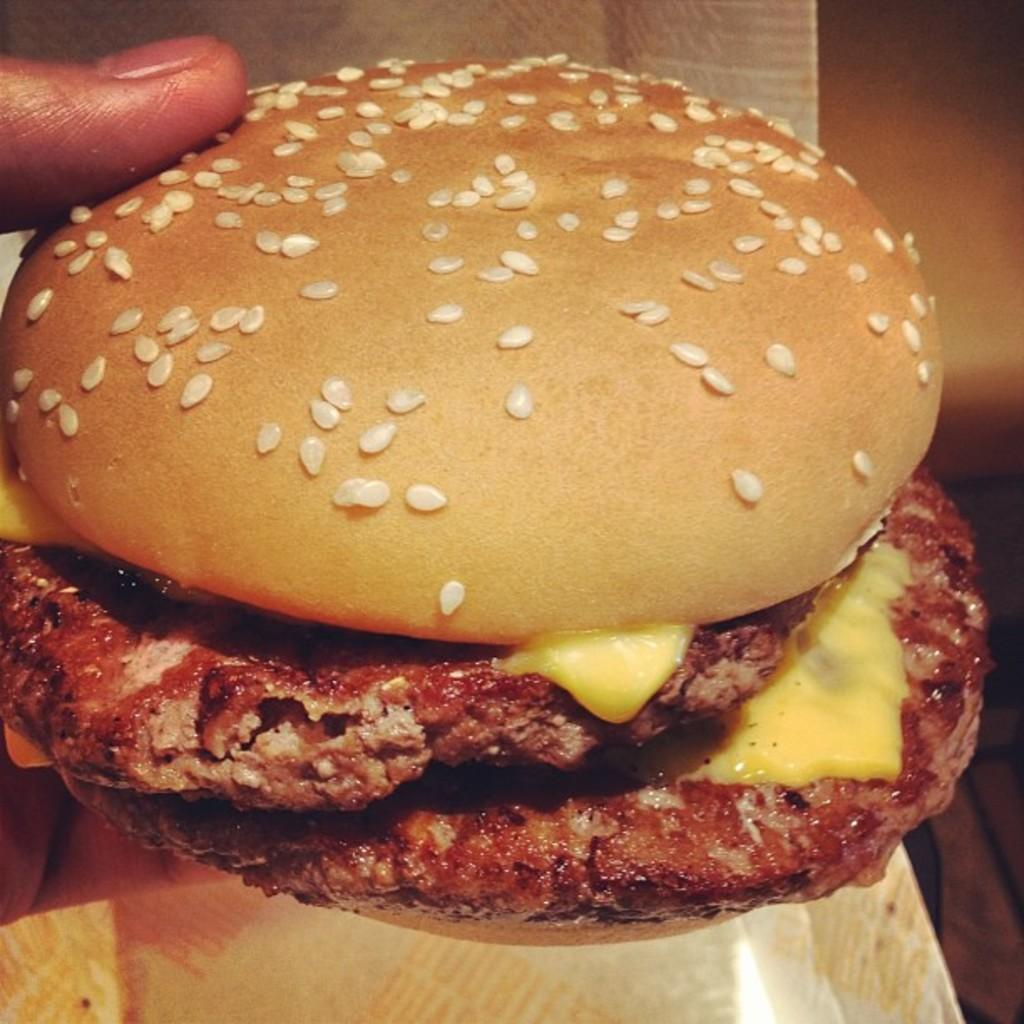What type of food can be seen in the image? The food in the image has brown and cream colors. Can you describe the appearance of the food? The food has brown and cream colors. Whose hand is visible in the image? There is a human hand visible in the image. What type of toy can be seen in the image? There is no toy present in the image. What material is the silk in the image made of? There is no silk present in the image. 